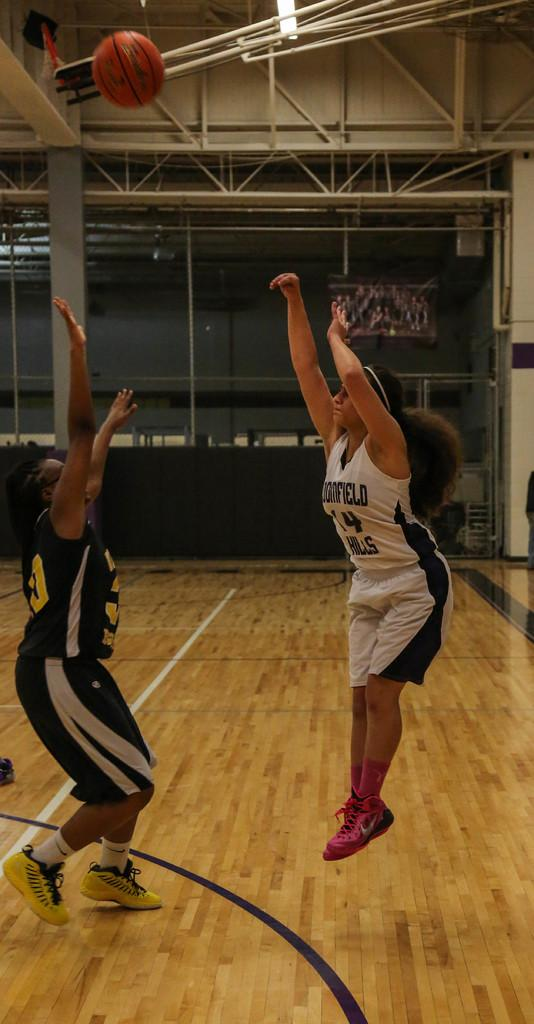How many women are in the image? There are two women in the image. What is one of the women doing? One of the women is jumping. What is in the air in the image? There is a ball in the air. What can be seen in the background of the image? There are rods visible in the background. What is at the top of the image? There is a light at the top of the image. What type of farm animals can be seen in the image? There are no farm animals present in the image. What is the women using to lead the ball in the image? The women are not using any sticks or leads to interact with the ball; they are simply jumping. 